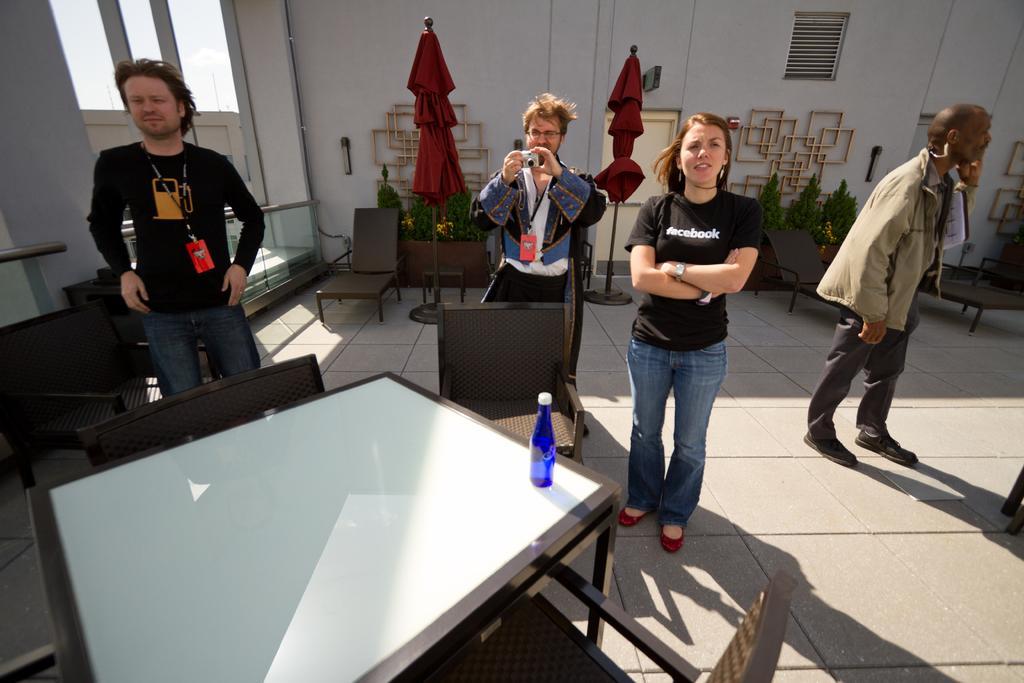How would you summarize this image in a sentence or two? Here in the center we can see two persons were standing. On the left side we can see one person is standing. And on the right side we can see another person is standing. In front of them we can see the table and chairs. And coming to the background we can see the wall. 